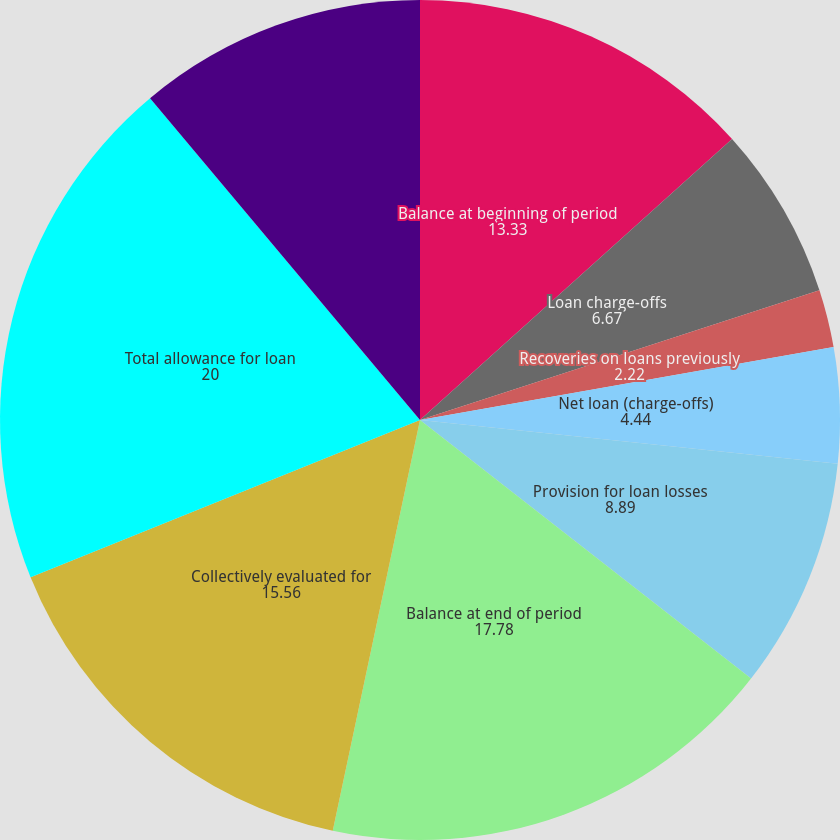Convert chart to OTSL. <chart><loc_0><loc_0><loc_500><loc_500><pie_chart><fcel>Balance at beginning of period<fcel>Loan charge-offs<fcel>Recoveries on loans previously<fcel>Net loan (charge-offs)<fcel>Provision for loan losses<fcel>Balance at end of period<fcel>As a percentage of total loans<fcel>Collectively evaluated for<fcel>Total allowance for loan<fcel>Individually evaluated for<nl><fcel>13.33%<fcel>6.67%<fcel>2.22%<fcel>4.44%<fcel>8.89%<fcel>17.78%<fcel>0.0%<fcel>15.56%<fcel>20.0%<fcel>11.11%<nl></chart> 